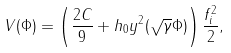<formula> <loc_0><loc_0><loc_500><loc_500>V ( \Phi ) = \left ( \frac { 2 C } { 9 } + h _ { 0 } y ^ { 2 } ( \sqrt { \gamma } \Phi ) \right ) \frac { f _ { i } ^ { 2 } } { 2 } ,</formula> 